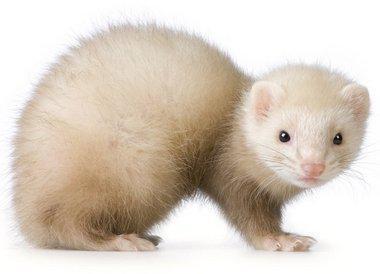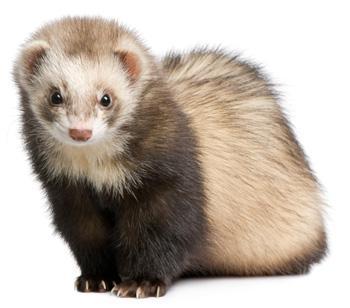The first image is the image on the left, the second image is the image on the right. Considering the images on both sides, is "One of the images shows an animal being held by a human." valid? Answer yes or no. No. The first image is the image on the left, the second image is the image on the right. For the images displayed, is the sentence "There is only one ferret in each of the images." factually correct? Answer yes or no. Yes. 